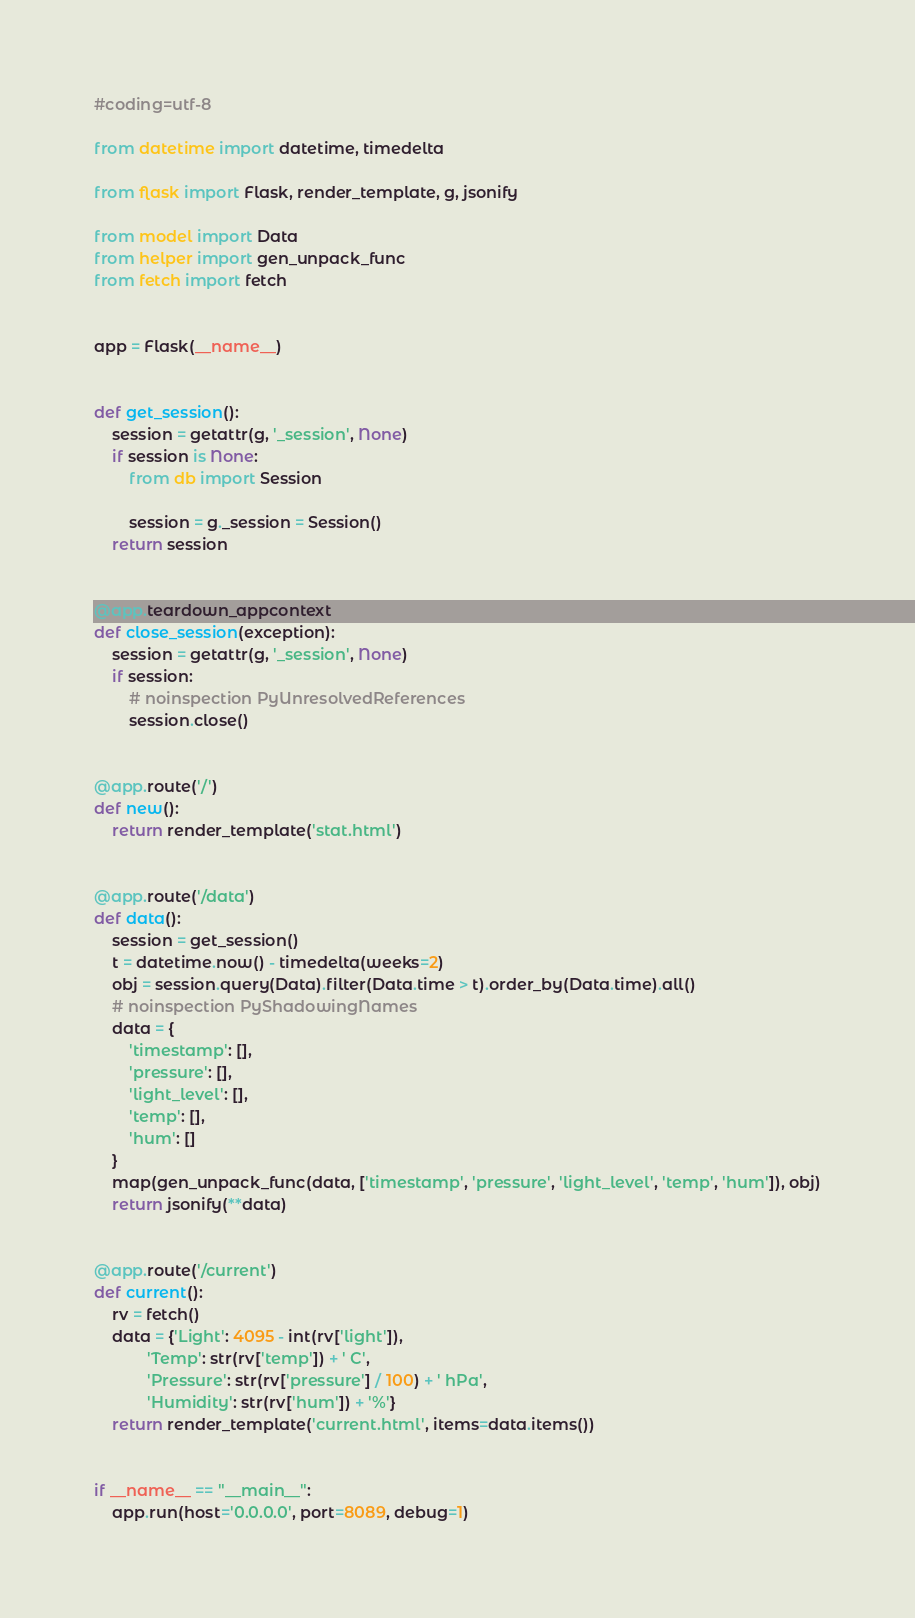Convert code to text. <code><loc_0><loc_0><loc_500><loc_500><_Python_>#coding=utf-8

from datetime import datetime, timedelta

from flask import Flask, render_template, g, jsonify

from model import Data
from helper import gen_unpack_func
from fetch import fetch


app = Flask(__name__)


def get_session():
    session = getattr(g, '_session', None)
    if session is None:
        from db import Session

        session = g._session = Session()
    return session


@app.teardown_appcontext
def close_session(exception):
    session = getattr(g, '_session', None)
    if session:
        # noinspection PyUnresolvedReferences
        session.close()


@app.route('/')
def new():
    return render_template('stat.html')


@app.route('/data')
def data():
    session = get_session()
    t = datetime.now() - timedelta(weeks=2)
    obj = session.query(Data).filter(Data.time > t).order_by(Data.time).all()
    # noinspection PyShadowingNames
    data = {
        'timestamp': [],
        'pressure': [],
        'light_level': [],
        'temp': [],
        'hum': []
    }
    map(gen_unpack_func(data, ['timestamp', 'pressure', 'light_level', 'temp', 'hum']), obj)
    return jsonify(**data)


@app.route('/current')
def current():
    rv = fetch()
    data = {'Light': 4095 - int(rv['light']),
            'Temp': str(rv['temp']) + ' C',
            'Pressure': str(rv['pressure'] / 100) + ' hPa',
            'Humidity': str(rv['hum']) + '%'}
    return render_template('current.html', items=data.items())


if __name__ == "__main__":
    app.run(host='0.0.0.0', port=8089, debug=1)</code> 